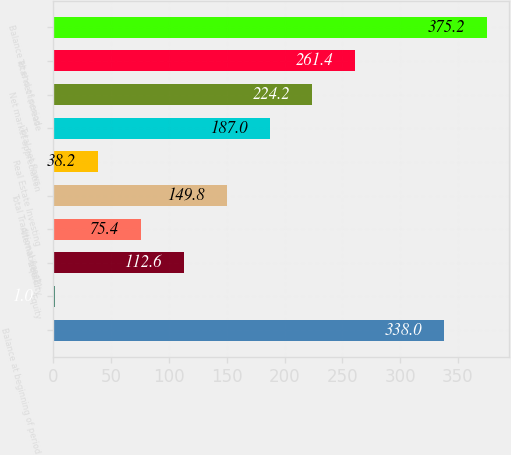<chart> <loc_0><loc_0><loc_500><loc_500><bar_chart><fcel>Balance at beginning of period<fcel>Equity<fcel>Liquidity<fcel>Alternatives(2)<fcel>Total Traditional Asset<fcel>Real Estate Investing<fcel>Total net flows<fcel>Net market appreciation<fcel>Total net increase<fcel>Balance at end of period<nl><fcel>338<fcel>1<fcel>112.6<fcel>75.4<fcel>149.8<fcel>38.2<fcel>187<fcel>224.2<fcel>261.4<fcel>375.2<nl></chart> 